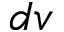<formula> <loc_0><loc_0><loc_500><loc_500>d v</formula> 